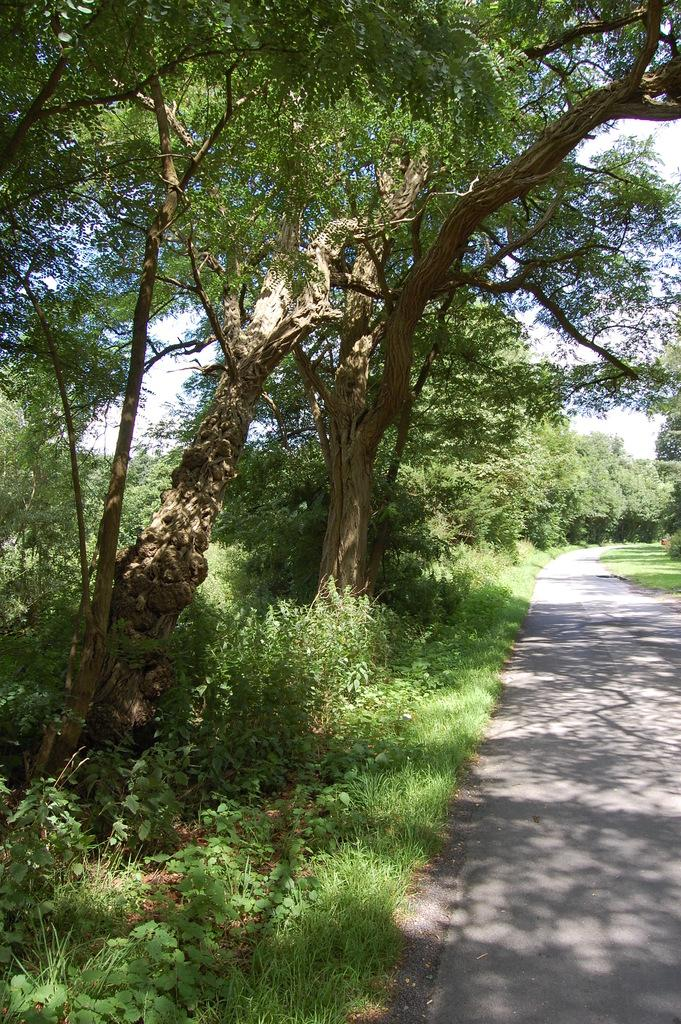What type of vegetation can be seen in the image? There are trees and plants in the image. What else can be seen in the image besides vegetation? There is a road and grass in the image. What is visible in the background of the image? The sky is visible in the image. What type of feather can be seen on the duck in the image? There is no duck or feather present in the image. What part of the body is visible in the image? The image does not show any body parts; it features trees, plants, a road, grass, and the sky. 